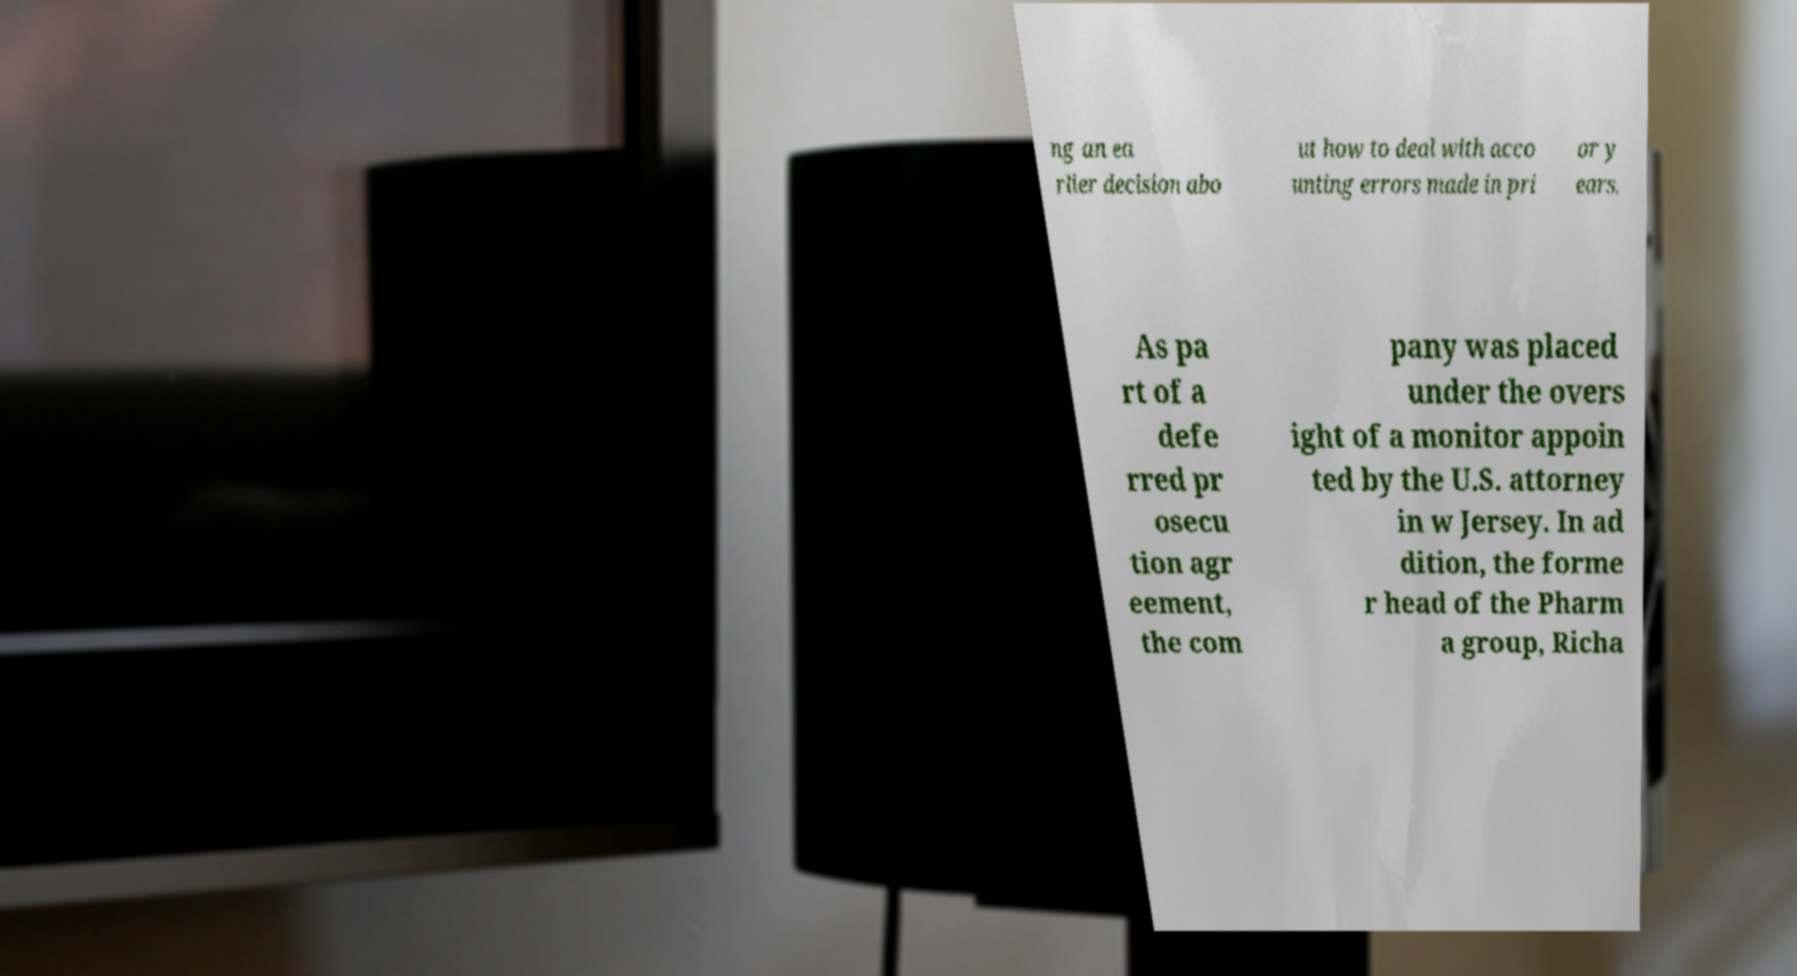Can you read and provide the text displayed in the image?This photo seems to have some interesting text. Can you extract and type it out for me? ng an ea rlier decision abo ut how to deal with acco unting errors made in pri or y ears. As pa rt of a defe rred pr osecu tion agr eement, the com pany was placed under the overs ight of a monitor appoin ted by the U.S. attorney in w Jersey. In ad dition, the forme r head of the Pharm a group, Richa 